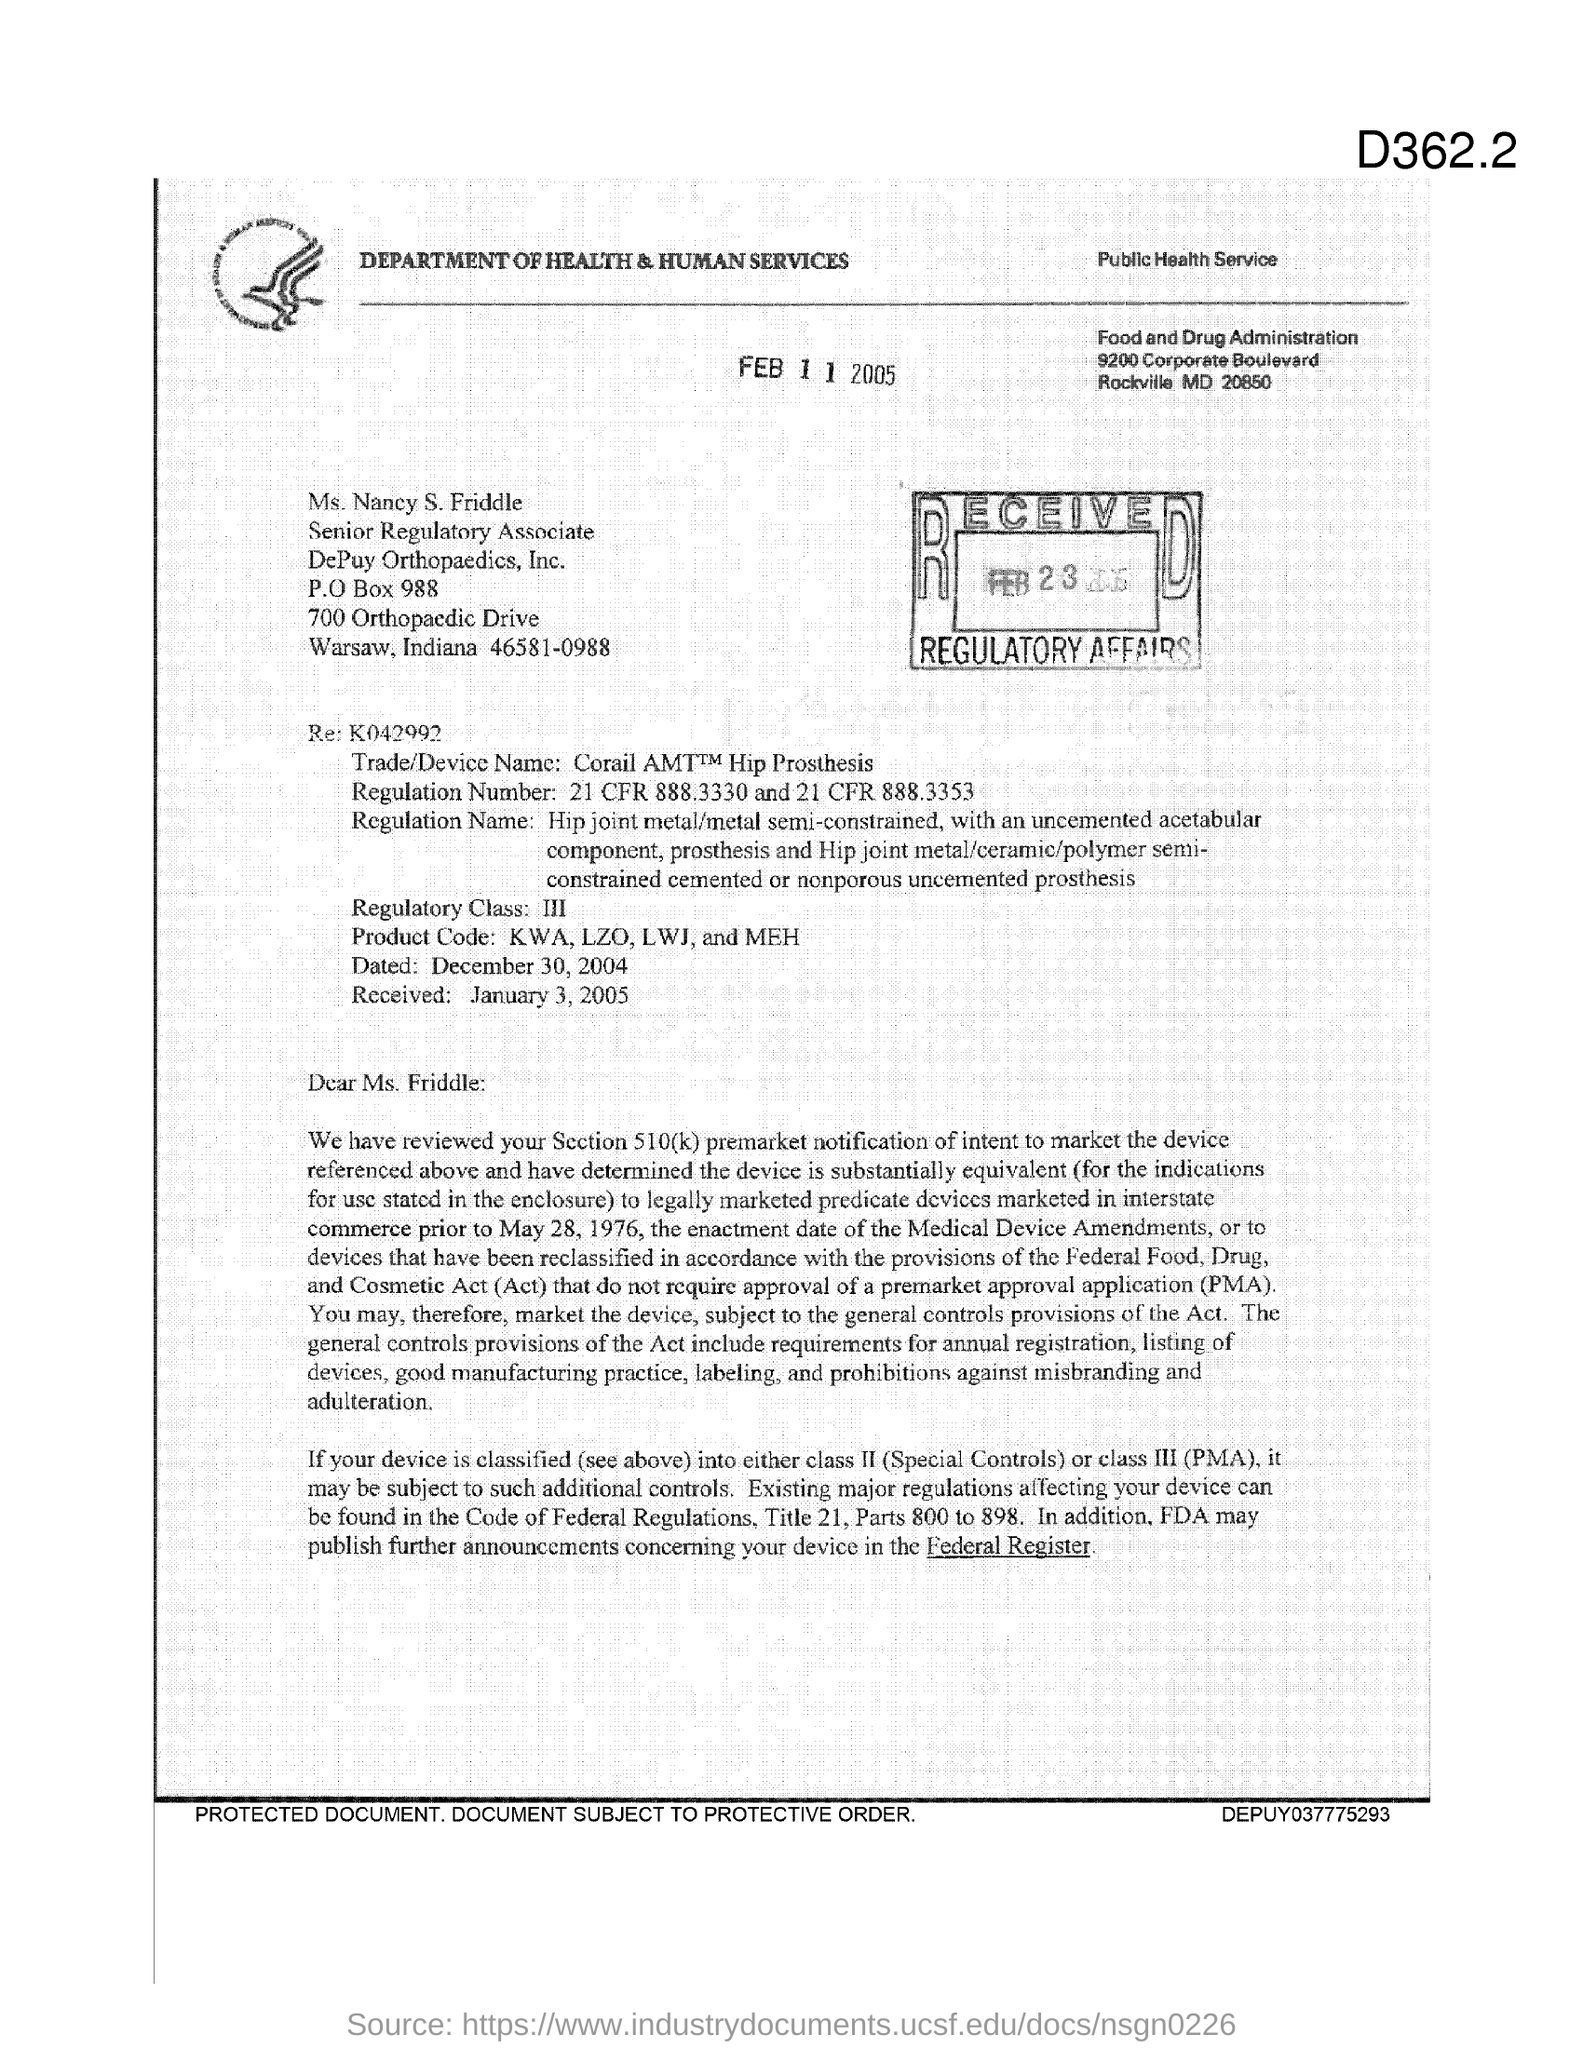Specify some key components in this picture. The Regulatory Class is III. DePuy Orthopaedics, Inc. is located in the state of Indiana. Ms. Nancy S. Friddle holds the position of Senior Regulatory Associate. The Food and Drug Administration (FDA) is located in the state of Maryland (MD). The postal box number of DePuy Orthopaedics, Inc. is 988-xxxx. 